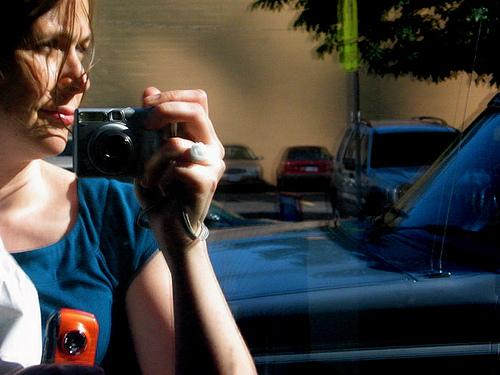What can be done using the orange thing?

Choices:
A) fly around
B) lock house
C) eat food
D) take pictures take pictures 